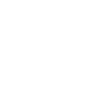<code> <loc_0><loc_0><loc_500><loc_500><_YAML_>    
</code> 